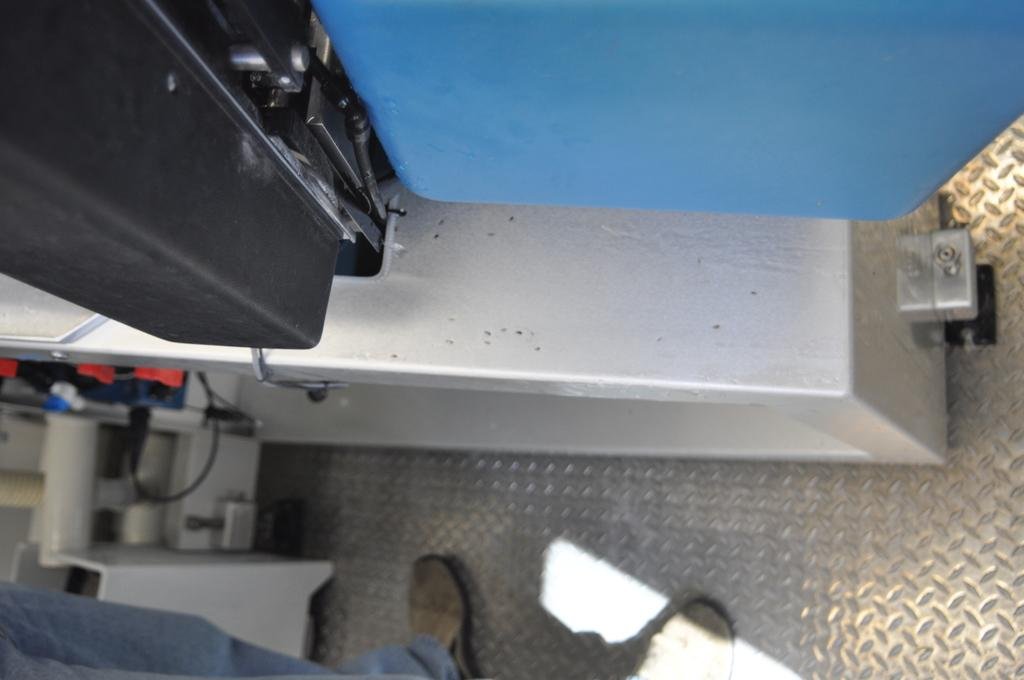What is present in the image? There is a person in the image. Can you describe the setting or location of the person? The person is inside a vehicle. What type of goose can be seen sitting on the furniture in the image? There is no goose or furniture present in the image. 